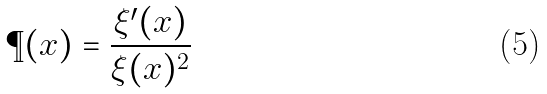<formula> <loc_0><loc_0><loc_500><loc_500>\P ( x ) = \frac { \xi ^ { \prime } ( x ) } { \xi ( x ) ^ { 2 } }</formula> 